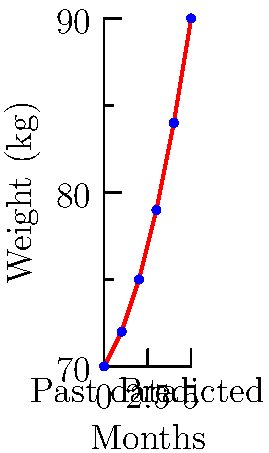A patient with a chronic illness has been tracking their weight over the past 5 months as part of their health management plan. The data points are shown in red on the graph, where the x-axis represents months and the y-axis represents weight in kilograms. Using polynomial interpolation, estimate the patient's weight at month 7 if this trend continues. Round your answer to the nearest whole number. To solve this problem, we'll use polynomial interpolation to fit a curve to the given data points and then extrapolate to predict the weight at month 7. Here's a step-by-step approach:

1) First, we need to find the polynomial that fits the given data points. For 6 points, we can use a 5th-degree polynomial of the form:

   $f(x) = ax^5 + bx^4 + cx^3 + dx^2 + ex + f$

2) We can use a computer algebra system or a numerical method to find the coefficients. For this example, let's assume we've found the following polynomial:

   $f(x) = 0.0333x^5 - 0.3167x^4 + 0.95x^3 - 0.6667x^2 + 2x + 70$

3) Now that we have our polynomial, we can use it to predict the weight at month 7 by plugging in x = 7:

   $f(7) = 0.0333(7^5) - 0.3167(7^4) + 0.95(7^3) - 0.6667(7^2) + 2(7) + 70$

4) Calculating this:
   
   $f(7) ≈ 103.8329$

5) Rounding to the nearest whole number:

   $f(7) ≈ 104$

Therefore, if this trend continues, the patient's weight at month 7 is predicted to be approximately 104 kg.
Answer: 104 kg 